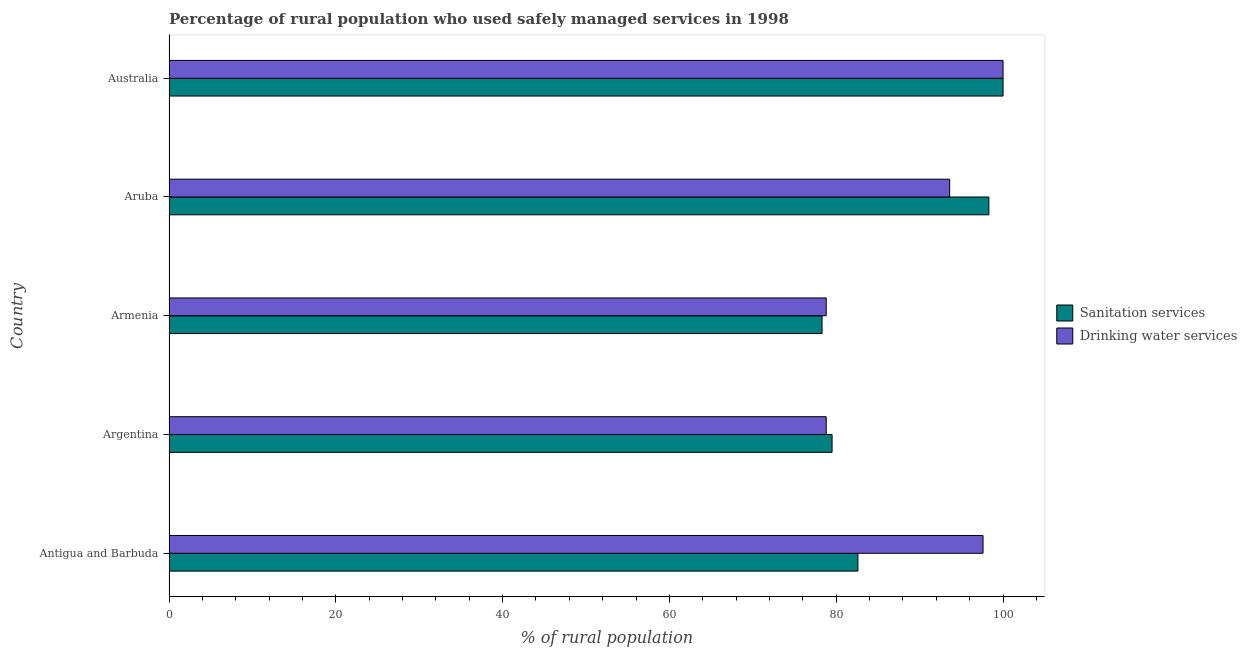How many different coloured bars are there?
Offer a terse response. 2. How many groups of bars are there?
Provide a succinct answer. 5. Are the number of bars per tick equal to the number of legend labels?
Your answer should be compact. Yes. How many bars are there on the 5th tick from the bottom?
Provide a short and direct response. 2. What is the percentage of rural population who used sanitation services in Aruba?
Provide a succinct answer. 98.3. Across all countries, what is the maximum percentage of rural population who used drinking water services?
Provide a short and direct response. 100. Across all countries, what is the minimum percentage of rural population who used drinking water services?
Provide a succinct answer. 78.8. In which country was the percentage of rural population who used drinking water services maximum?
Ensure brevity in your answer.  Australia. In which country was the percentage of rural population who used sanitation services minimum?
Offer a terse response. Armenia. What is the total percentage of rural population who used drinking water services in the graph?
Keep it short and to the point. 448.8. What is the difference between the percentage of rural population who used drinking water services in Antigua and Barbuda and that in Armenia?
Keep it short and to the point. 18.8. What is the difference between the percentage of rural population who used drinking water services in Australia and the percentage of rural population who used sanitation services in Armenia?
Provide a short and direct response. 21.7. What is the average percentage of rural population who used drinking water services per country?
Offer a terse response. 89.76. What is the difference between the percentage of rural population who used drinking water services and percentage of rural population who used sanitation services in Australia?
Make the answer very short. 0. Is the difference between the percentage of rural population who used drinking water services in Antigua and Barbuda and Aruba greater than the difference between the percentage of rural population who used sanitation services in Antigua and Barbuda and Aruba?
Provide a short and direct response. Yes. What is the difference between the highest and the lowest percentage of rural population who used drinking water services?
Your answer should be compact. 21.2. In how many countries, is the percentage of rural population who used sanitation services greater than the average percentage of rural population who used sanitation services taken over all countries?
Your answer should be very brief. 2. What does the 1st bar from the top in Australia represents?
Give a very brief answer. Drinking water services. What does the 1st bar from the bottom in Argentina represents?
Offer a terse response. Sanitation services. How many bars are there?
Ensure brevity in your answer.  10. Are all the bars in the graph horizontal?
Offer a very short reply. Yes. Are the values on the major ticks of X-axis written in scientific E-notation?
Offer a very short reply. No. Does the graph contain any zero values?
Make the answer very short. No. Where does the legend appear in the graph?
Provide a succinct answer. Center right. How many legend labels are there?
Provide a short and direct response. 2. What is the title of the graph?
Offer a terse response. Percentage of rural population who used safely managed services in 1998. Does "Nitrous oxide emissions" appear as one of the legend labels in the graph?
Offer a terse response. No. What is the label or title of the X-axis?
Your response must be concise. % of rural population. What is the % of rural population of Sanitation services in Antigua and Barbuda?
Your answer should be very brief. 82.6. What is the % of rural population in Drinking water services in Antigua and Barbuda?
Your answer should be compact. 97.6. What is the % of rural population of Sanitation services in Argentina?
Your answer should be very brief. 79.5. What is the % of rural population of Drinking water services in Argentina?
Keep it short and to the point. 78.8. What is the % of rural population of Sanitation services in Armenia?
Keep it short and to the point. 78.3. What is the % of rural population of Drinking water services in Armenia?
Ensure brevity in your answer.  78.8. What is the % of rural population of Sanitation services in Aruba?
Keep it short and to the point. 98.3. What is the % of rural population of Drinking water services in Aruba?
Your answer should be compact. 93.6. Across all countries, what is the minimum % of rural population in Sanitation services?
Make the answer very short. 78.3. Across all countries, what is the minimum % of rural population in Drinking water services?
Your answer should be very brief. 78.8. What is the total % of rural population of Sanitation services in the graph?
Keep it short and to the point. 438.7. What is the total % of rural population in Drinking water services in the graph?
Make the answer very short. 448.8. What is the difference between the % of rural population of Sanitation services in Antigua and Barbuda and that in Armenia?
Offer a very short reply. 4.3. What is the difference between the % of rural population of Drinking water services in Antigua and Barbuda and that in Armenia?
Your response must be concise. 18.8. What is the difference between the % of rural population in Sanitation services in Antigua and Barbuda and that in Aruba?
Give a very brief answer. -15.7. What is the difference between the % of rural population in Sanitation services in Antigua and Barbuda and that in Australia?
Keep it short and to the point. -17.4. What is the difference between the % of rural population in Sanitation services in Argentina and that in Aruba?
Give a very brief answer. -18.8. What is the difference between the % of rural population of Drinking water services in Argentina and that in Aruba?
Your answer should be very brief. -14.8. What is the difference between the % of rural population in Sanitation services in Argentina and that in Australia?
Offer a terse response. -20.5. What is the difference between the % of rural population in Drinking water services in Argentina and that in Australia?
Provide a succinct answer. -21.2. What is the difference between the % of rural population in Sanitation services in Armenia and that in Aruba?
Offer a very short reply. -20. What is the difference between the % of rural population in Drinking water services in Armenia and that in Aruba?
Give a very brief answer. -14.8. What is the difference between the % of rural population of Sanitation services in Armenia and that in Australia?
Keep it short and to the point. -21.7. What is the difference between the % of rural population of Drinking water services in Armenia and that in Australia?
Give a very brief answer. -21.2. What is the difference between the % of rural population in Sanitation services in Aruba and that in Australia?
Your answer should be very brief. -1.7. What is the difference between the % of rural population of Drinking water services in Aruba and that in Australia?
Offer a terse response. -6.4. What is the difference between the % of rural population in Sanitation services in Antigua and Barbuda and the % of rural population in Drinking water services in Armenia?
Make the answer very short. 3.8. What is the difference between the % of rural population in Sanitation services in Antigua and Barbuda and the % of rural population in Drinking water services in Australia?
Offer a terse response. -17.4. What is the difference between the % of rural population of Sanitation services in Argentina and the % of rural population of Drinking water services in Armenia?
Ensure brevity in your answer.  0.7. What is the difference between the % of rural population in Sanitation services in Argentina and the % of rural population in Drinking water services in Aruba?
Make the answer very short. -14.1. What is the difference between the % of rural population in Sanitation services in Argentina and the % of rural population in Drinking water services in Australia?
Provide a succinct answer. -20.5. What is the difference between the % of rural population in Sanitation services in Armenia and the % of rural population in Drinking water services in Aruba?
Your answer should be very brief. -15.3. What is the difference between the % of rural population of Sanitation services in Armenia and the % of rural population of Drinking water services in Australia?
Provide a short and direct response. -21.7. What is the difference between the % of rural population in Sanitation services in Aruba and the % of rural population in Drinking water services in Australia?
Provide a succinct answer. -1.7. What is the average % of rural population in Sanitation services per country?
Your answer should be very brief. 87.74. What is the average % of rural population of Drinking water services per country?
Your response must be concise. 89.76. What is the difference between the % of rural population in Sanitation services and % of rural population in Drinking water services in Argentina?
Keep it short and to the point. 0.7. What is the difference between the % of rural population of Sanitation services and % of rural population of Drinking water services in Australia?
Provide a succinct answer. 0. What is the ratio of the % of rural population of Sanitation services in Antigua and Barbuda to that in Argentina?
Your answer should be very brief. 1.04. What is the ratio of the % of rural population of Drinking water services in Antigua and Barbuda to that in Argentina?
Offer a terse response. 1.24. What is the ratio of the % of rural population of Sanitation services in Antigua and Barbuda to that in Armenia?
Provide a succinct answer. 1.05. What is the ratio of the % of rural population in Drinking water services in Antigua and Barbuda to that in Armenia?
Offer a very short reply. 1.24. What is the ratio of the % of rural population in Sanitation services in Antigua and Barbuda to that in Aruba?
Provide a short and direct response. 0.84. What is the ratio of the % of rural population of Drinking water services in Antigua and Barbuda to that in Aruba?
Offer a terse response. 1.04. What is the ratio of the % of rural population of Sanitation services in Antigua and Barbuda to that in Australia?
Provide a succinct answer. 0.83. What is the ratio of the % of rural population of Drinking water services in Antigua and Barbuda to that in Australia?
Offer a very short reply. 0.98. What is the ratio of the % of rural population in Sanitation services in Argentina to that in Armenia?
Offer a very short reply. 1.02. What is the ratio of the % of rural population of Drinking water services in Argentina to that in Armenia?
Give a very brief answer. 1. What is the ratio of the % of rural population in Sanitation services in Argentina to that in Aruba?
Offer a terse response. 0.81. What is the ratio of the % of rural population in Drinking water services in Argentina to that in Aruba?
Provide a succinct answer. 0.84. What is the ratio of the % of rural population in Sanitation services in Argentina to that in Australia?
Provide a succinct answer. 0.8. What is the ratio of the % of rural population in Drinking water services in Argentina to that in Australia?
Make the answer very short. 0.79. What is the ratio of the % of rural population in Sanitation services in Armenia to that in Aruba?
Provide a short and direct response. 0.8. What is the ratio of the % of rural population in Drinking water services in Armenia to that in Aruba?
Give a very brief answer. 0.84. What is the ratio of the % of rural population in Sanitation services in Armenia to that in Australia?
Your answer should be very brief. 0.78. What is the ratio of the % of rural population in Drinking water services in Armenia to that in Australia?
Provide a short and direct response. 0.79. What is the ratio of the % of rural population in Drinking water services in Aruba to that in Australia?
Keep it short and to the point. 0.94. What is the difference between the highest and the lowest % of rural population in Sanitation services?
Your answer should be very brief. 21.7. What is the difference between the highest and the lowest % of rural population in Drinking water services?
Make the answer very short. 21.2. 